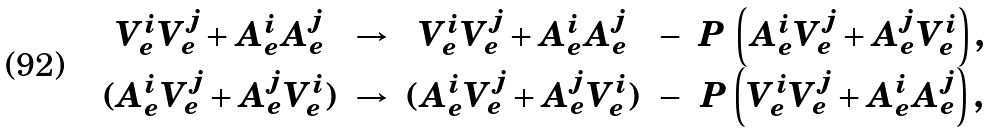Convert formula to latex. <formula><loc_0><loc_0><loc_500><loc_500>\begin{array} { c l c l c } V _ { e } ^ { i } V _ { e } ^ { j } + A _ { e } ^ { i } A _ { e } ^ { j } & \rightarrow & V _ { e } ^ { i } V _ { e } ^ { j } + A _ { e } ^ { i } A _ { e } ^ { j } & - & P \, \left ( A _ { e } ^ { i } V _ { e } ^ { j } + A _ { e } ^ { j } V _ { e } ^ { i } \right ) , \\ ( A _ { e } ^ { i } V _ { e } ^ { j } + A _ { e } ^ { j } V _ { e } ^ { i } ) & \rightarrow & ( A _ { e } ^ { i } V _ { e } ^ { j } + A _ { e } ^ { j } V _ { e } ^ { i } ) & - & P \left ( V _ { e } ^ { i } V _ { e } ^ { j } + A _ { e } ^ { i } A _ { e } ^ { j } \right ) , \end{array}</formula> 